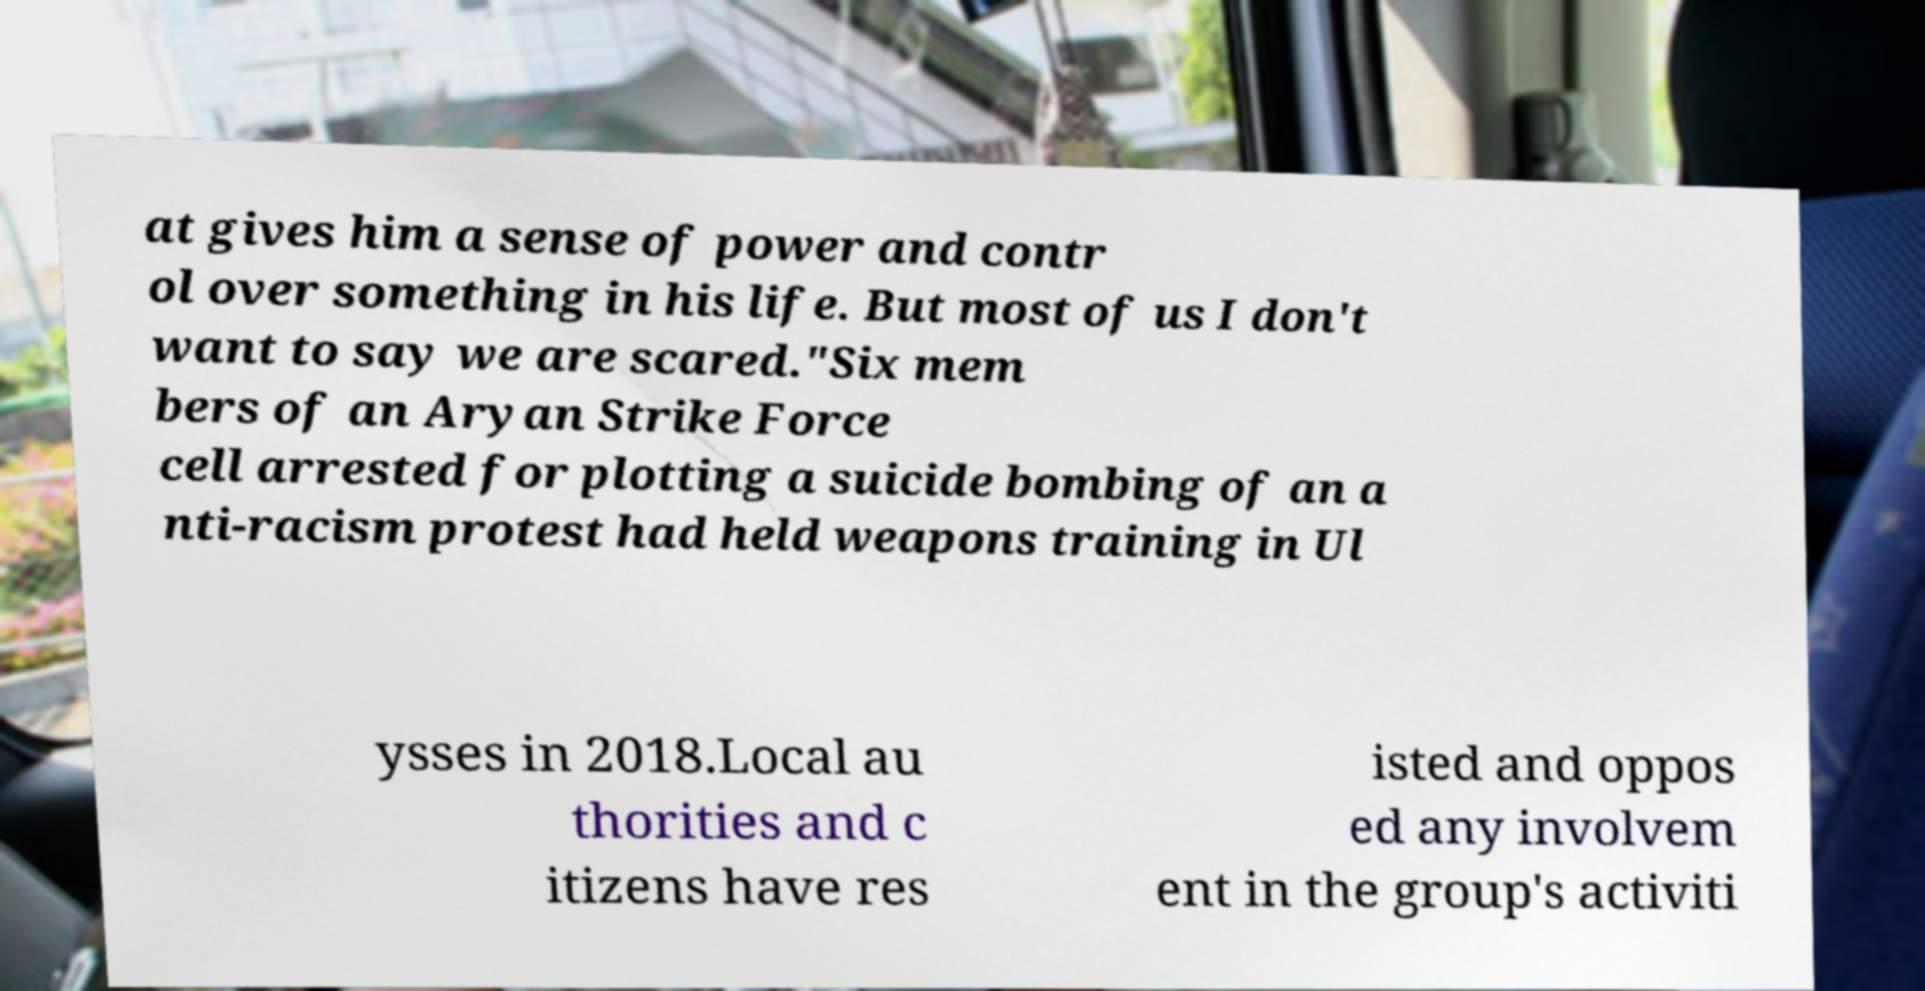Can you accurately transcribe the text from the provided image for me? at gives him a sense of power and contr ol over something in his life. But most of us I don't want to say we are scared."Six mem bers of an Aryan Strike Force cell arrested for plotting a suicide bombing of an a nti-racism protest had held weapons training in Ul ysses in 2018.Local au thorities and c itizens have res isted and oppos ed any involvem ent in the group's activiti 